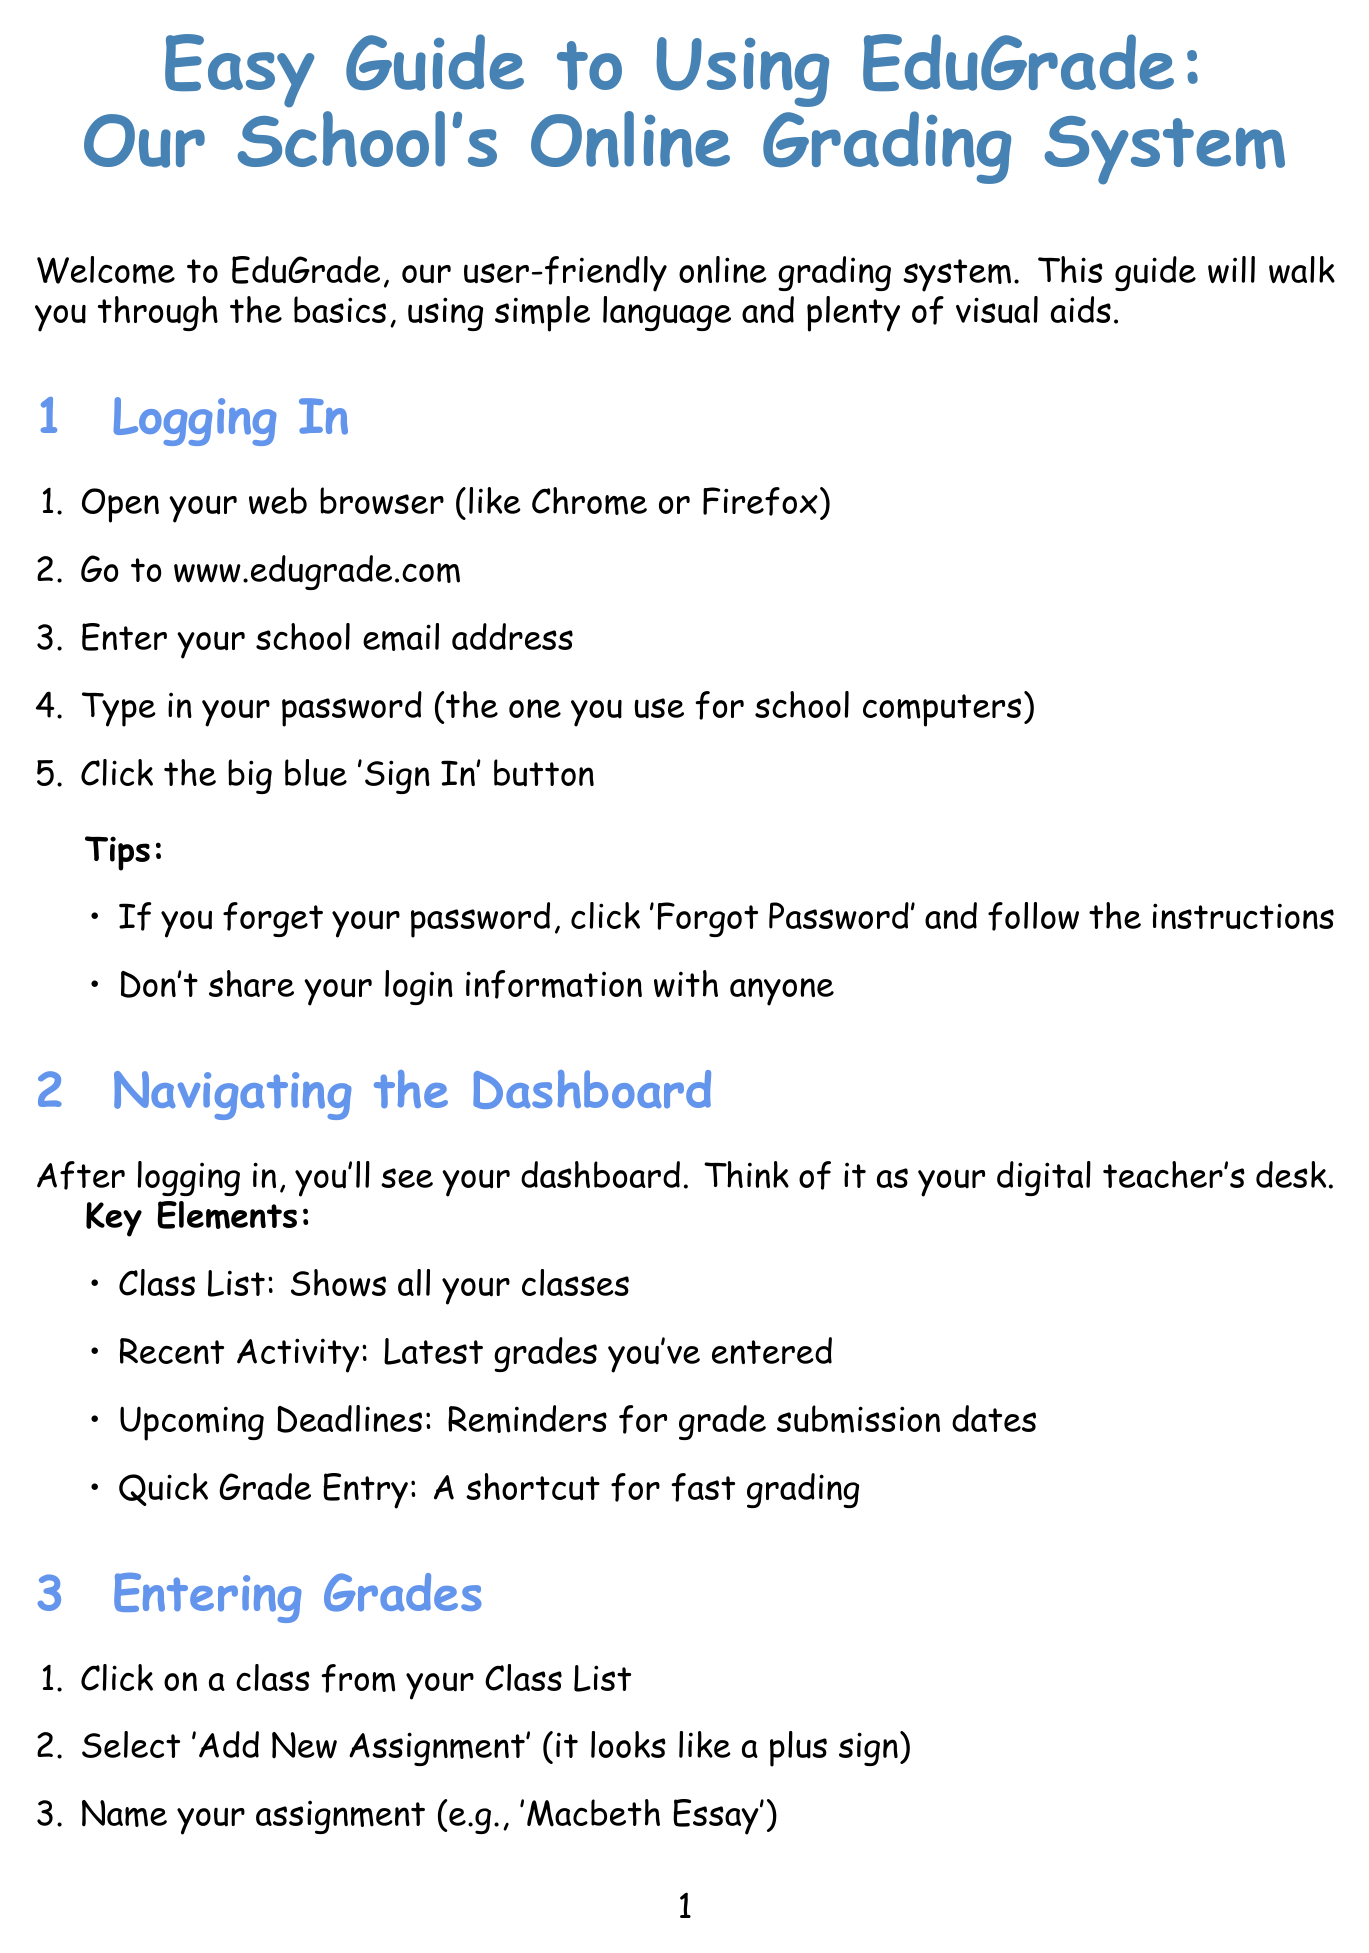What is the title of the manual? The title of the manual is found at the beginning of the document and introduces the system covered in the guide.
Answer: Easy Guide to Using EduGrade: Our School's Online Grading System What is the email address for support? The document includes a section for troubleshooting common issues, which provides contact information for assistance.
Answer: support@edugrade.com How many steps are there in the 'Entering Grades' section? The number of steps is specified in the 'Entering Grades' section, detailing the process of entering grades.
Answer: 6 What can you choose for report type? The manual lists options available for generating reports in the corresponding section, indicating report types one can select.
Answer: Class Average, Individual Student Report What do you do if you can't find a student in your class list? This is addressed in the Troubleshooting section, which provides solutions for common issues encountered in the system.
Answer: Double-check the spelling or contact the school administration What does the 'Recent Activity' shows? The key elements of the dashboard offer information on what users can expect to see after logging in.
Answer: Latest grades you've entered How should you save grades? The steps and tips in the 'Entering Grades' section highlight the importance of saving changes appropriately.
Answer: Click 'Save' when you're done What should you do if the page won't load? The troubleshooting solutions suggest immediate actions when faced with loading issues on the EduGrade platform.
Answer: Try refreshing the page or clearing your browser cache 